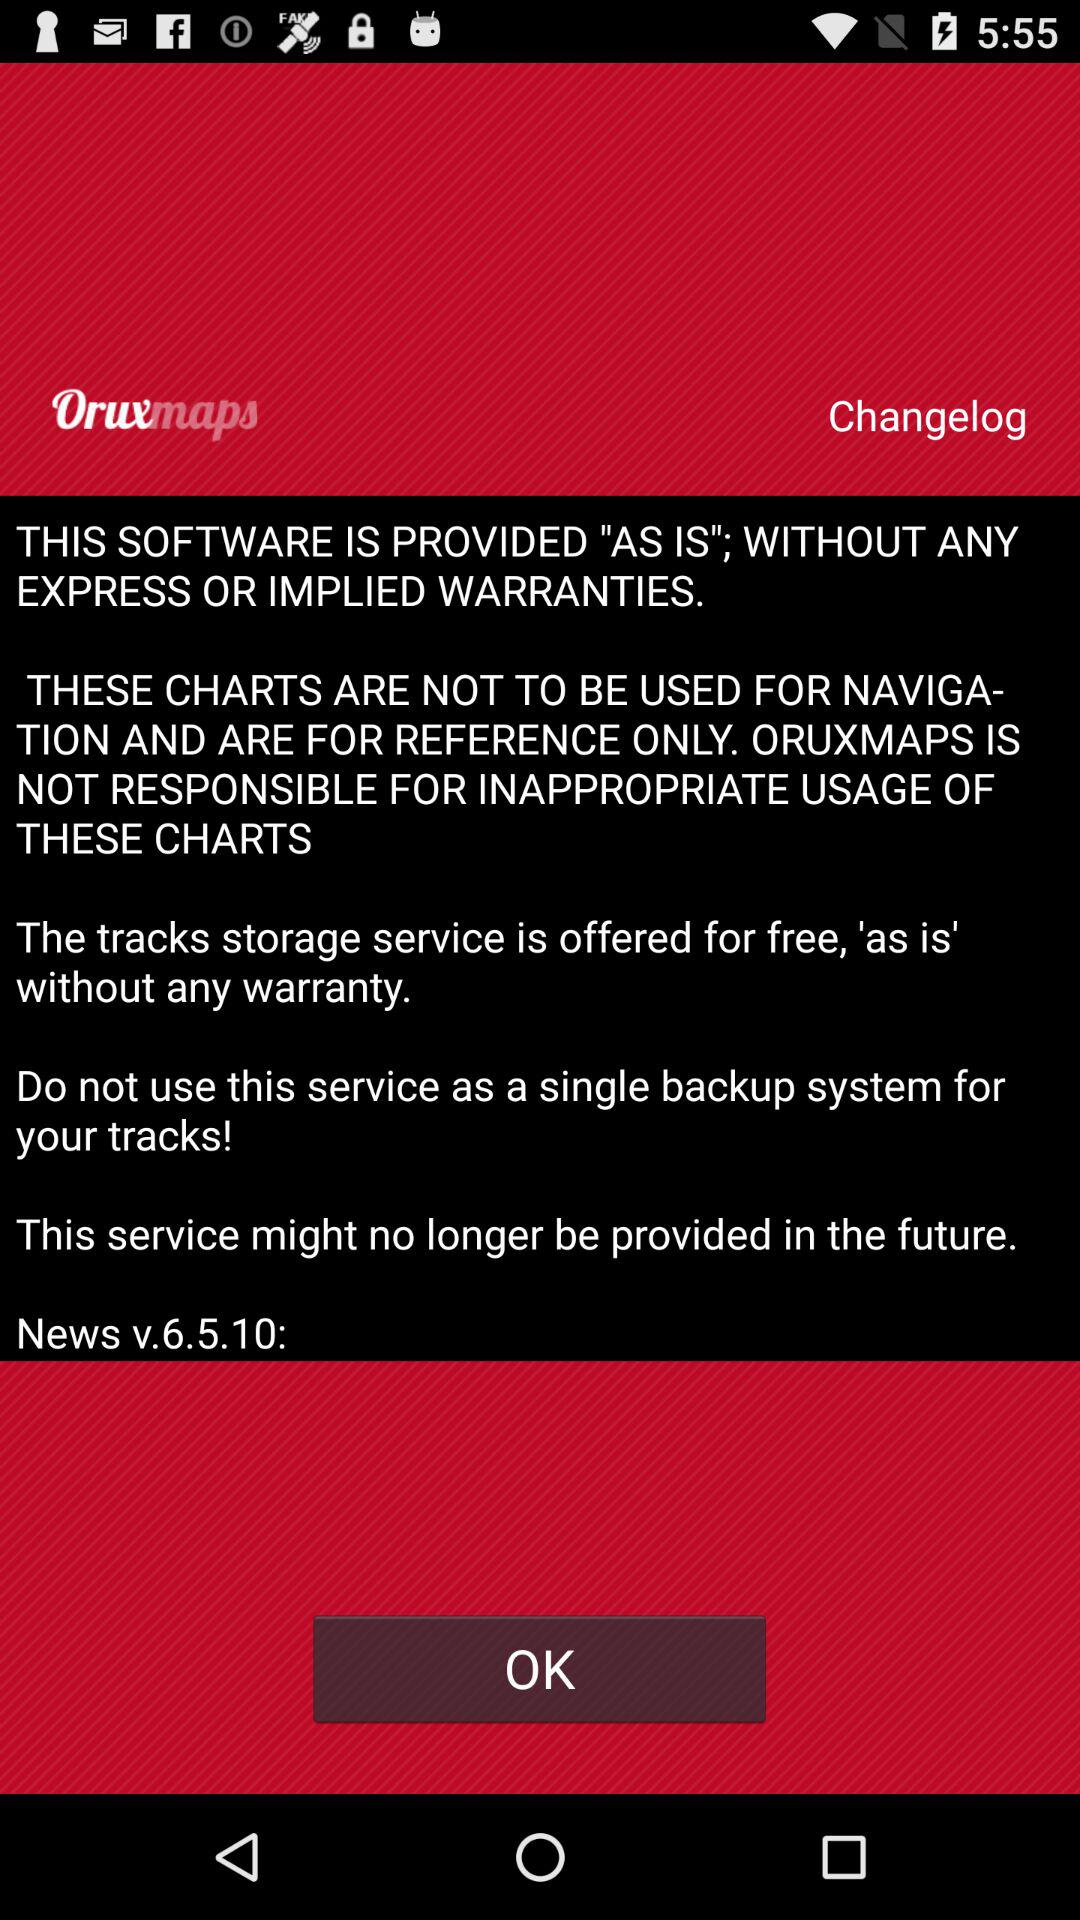What is the software name? The software name is Oruxmaps. 